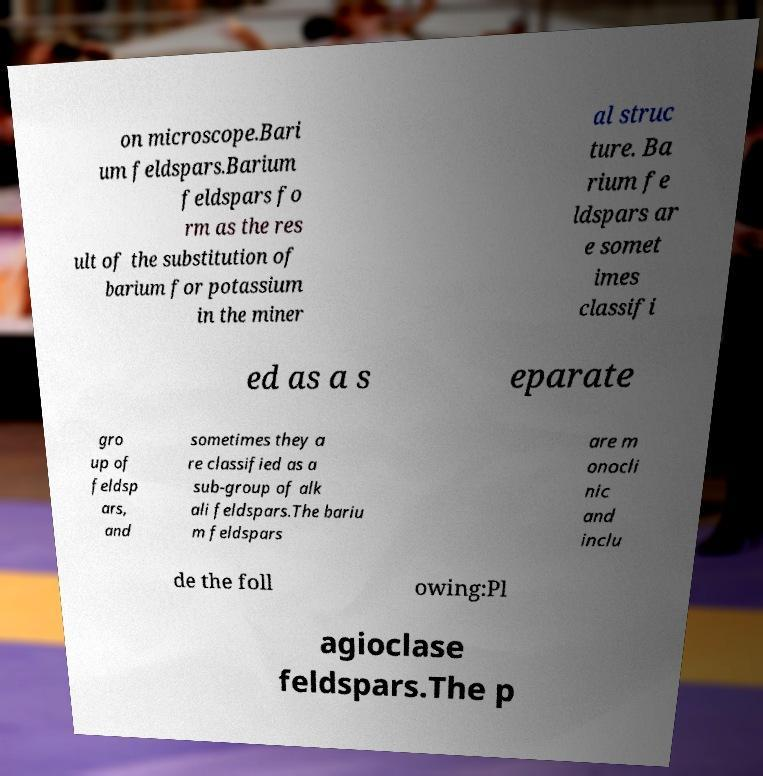Can you accurately transcribe the text from the provided image for me? on microscope.Bari um feldspars.Barium feldspars fo rm as the res ult of the substitution of barium for potassium in the miner al struc ture. Ba rium fe ldspars ar e somet imes classifi ed as a s eparate gro up of feldsp ars, and sometimes they a re classified as a sub-group of alk ali feldspars.The bariu m feldspars are m onocli nic and inclu de the foll owing:Pl agioclase feldspars.The p 